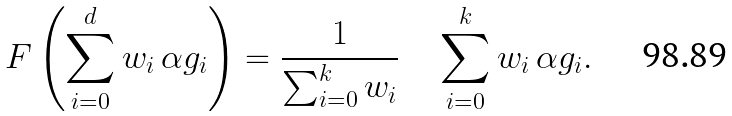<formula> <loc_0><loc_0><loc_500><loc_500>F \left ( \sum _ { i = 0 } ^ { d } w _ { i } \, \alpha g _ { i } \right ) = \frac { 1 } { \sum _ { i = 0 } ^ { k } w _ { i } } \quad \sum _ { i = 0 } ^ { k } w _ { i } \, \alpha g _ { i } .</formula> 